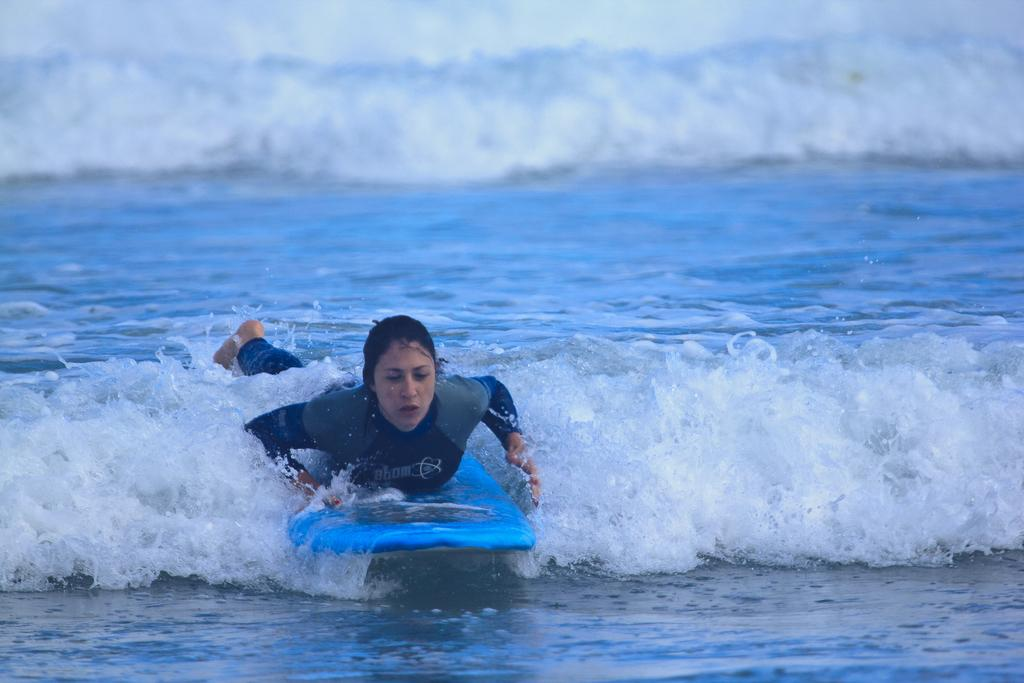Who is the main subject in the image? There is a woman in the image. What is the woman doing in the image? The woman is lying on a surfboard and surfing on the water. What type of cheese can be seen on the woman's surfboard in the image? There is no cheese present on the woman's surfboard in the image. What is the woman using to collect water while surfing in the image? There is no pail or any other object for collecting water visible in the image. 